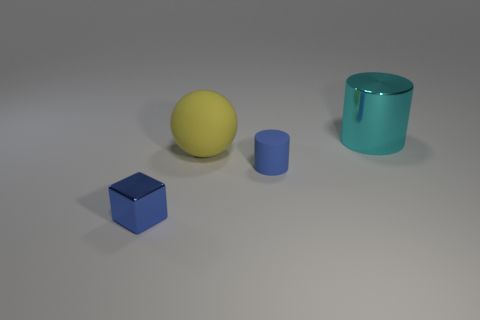Add 3 large red matte spheres. How many objects exist? 7 Subtract all cyan cylinders. How many cylinders are left? 1 Add 2 balls. How many balls exist? 3 Subtract 1 blue cubes. How many objects are left? 3 Subtract 1 spheres. How many spheres are left? 0 Subtract all gray cylinders. Subtract all purple blocks. How many cylinders are left? 2 Subtract all blue spheres. How many brown cubes are left? 0 Subtract all large purple matte cylinders. Subtract all blue objects. How many objects are left? 2 Add 1 cyan cylinders. How many cyan cylinders are left? 2 